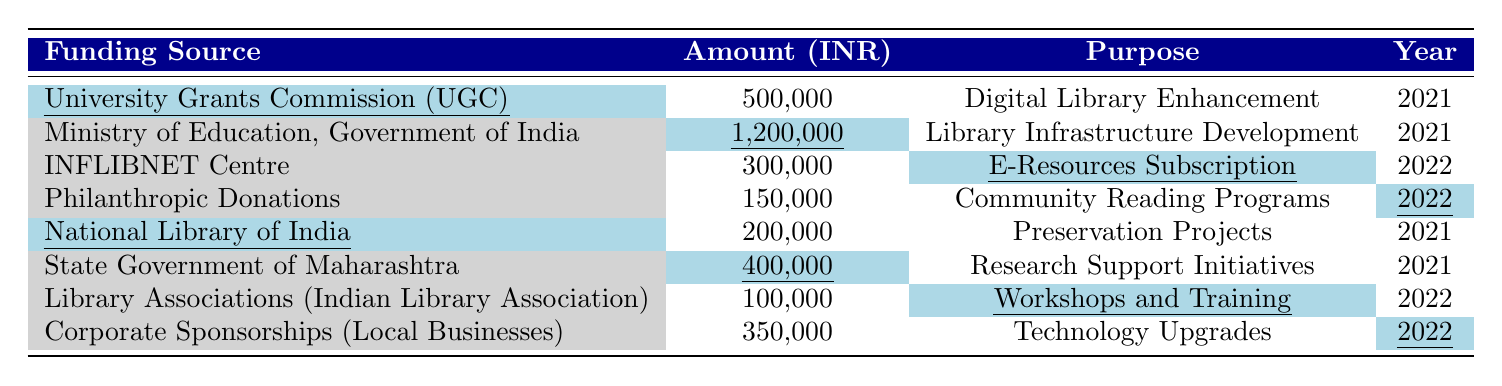What is the total amount received from the University Grants Commission (UGC)? The amount received from UGC is listed in the table as 500,000 INR.
Answer: 500,000 INR How much funding was allocated for Library Infrastructure Development? The funding amount for Library Infrastructure Development, as provided by the Ministry of Education, is 1,200,000 INR.
Answer: 1,200,000 INR Which year did the INFLIBNET Centre provide funding? According to the table, funding from the INFLIBNET Centre was provided in the year 2022.
Answer: 2022 How much was allocated for community reading programs in 2022? The table shows that philanthropic donations amounted to 150,000 INR for community reading programs in 2022.
Answer: 150,000 INR What is the total funding amount from all sources for the year 2021? Adding the amounts from each funding source in 2021: 500,000 (UGC) + 1,200,000 (Ministry of Education) + 200,000 (National Library of India) + 400,000 (State Government) = 2,300,000 INR.
Answer: 2,300,000 INR Is there any funding for workshops and training in 2021? The table does not list any funding for workshops and training in 2021; it was allocated only in 2022.
Answer: No What percentage of the total funding for 2022 comes from corporate sponsorships? The amounts for 2022 are: 300,000 (INFLIBNET Centre), 150,000 (Philanthropic Donations), 100,000 (Library Associations), and 350,000 (Corporate Sponsorships), which is a total of 900,000 INR. Corporate sponsorships amount to 350,000 INR. Therefore, the percentage is (350,000/900,000) * 100 = 38.89%.
Answer: 38.89% Which funding source had the smallest allocation in 2022? In 2022, the smallest allocation is from the Library Associations (Indian Library Association) with 100,000 INR for workshops and training.
Answer: 100,000 INR How much more funding was provided for Digital Library Enhancement compared to Preservation Projects? The amount for Digital Library Enhancement from UGC is 500,000 INR, while the amount for Preservation Projects from the National Library of India is 200,000 INR. Therefore, 500,000 - 200,000 = 300,000 INR more was provided.
Answer: 300,000 INR Which purpose received the highest funding in 2021? The highest funding in 2021 is for Library Infrastructure Development at 1,200,000 INR from the Ministry of Education.
Answer: Library Infrastructure Development 